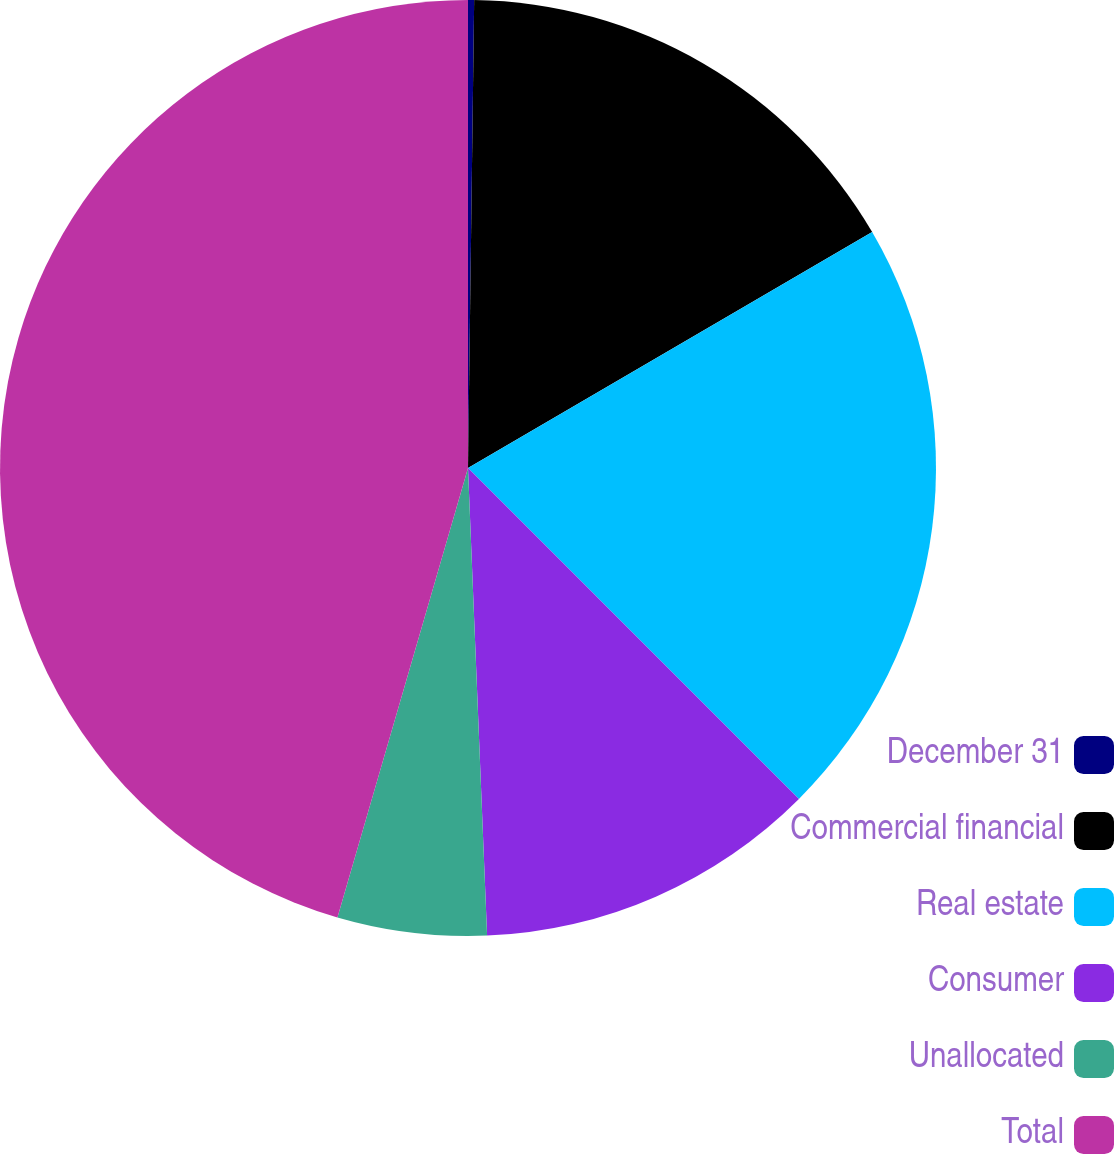Convert chart. <chart><loc_0><loc_0><loc_500><loc_500><pie_chart><fcel>December 31<fcel>Commercial financial<fcel>Real estate<fcel>Consumer<fcel>Unallocated<fcel>Total<nl><fcel>0.21%<fcel>16.38%<fcel>20.91%<fcel>11.85%<fcel>5.15%<fcel>45.5%<nl></chart> 